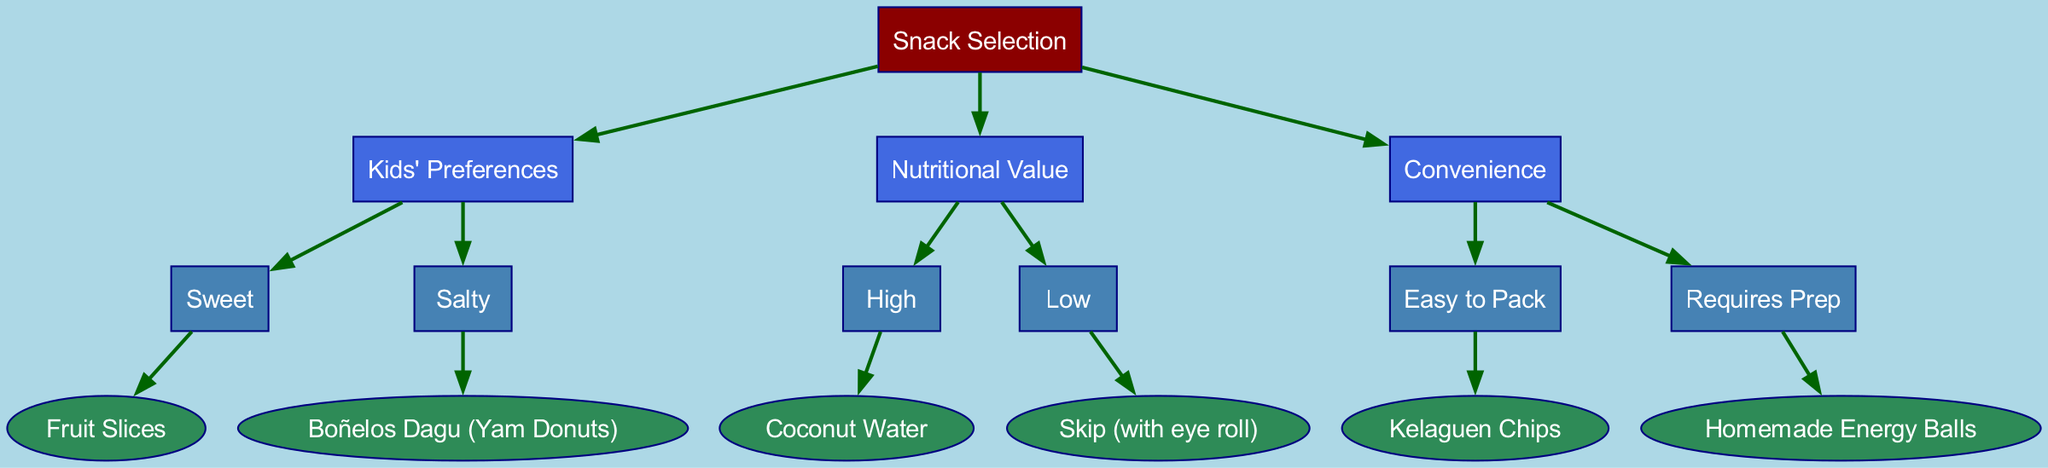What is the root node of the diagram? The root node is labeled "Snack Selection."
Answer: Snack Selection How many main branches are there? There are three main branches: Kids' Preferences, Nutritional Value, and Convenience.
Answer: 3 What snack is chosen if kids prefer something sweet? If kids prefer something sweet, the snack chosen is Fruit Slices.
Answer: Fruit Slices Which snack should be skipped if the nutritional value is low? If the nutritional value is low, the snack that should be skipped is indicated with "Skip (with eye roll)."
Answer: Skip (with eye roll) What is the snack option for high nutritional value? The snack option for high nutritional value is Coconut Water.
Answer: Coconut Water What’s the last snack on the Convenience branch? The last snack on the Convenience branch that requires prep is Homemade Energy Balls.
Answer: Homemade Energy Balls Which node leads to Boñelos Dagu? The node "Kids' Preferences" leads to Boñelos Dagu when the response is salty.
Answer: Kids' Preferences What snack is selected if the choice is easy to pack? If the choice is easy to pack, the selected snack is Kelaguen Chips.
Answer: Kelaguen Chips How is the "Skip (with eye roll)" leaf node related to other nodes? The "Skip (with eye roll)" leaf node is connected to the "Nutritional Value" branch under the low nutritional value condition.
Answer: Nutritional Value 